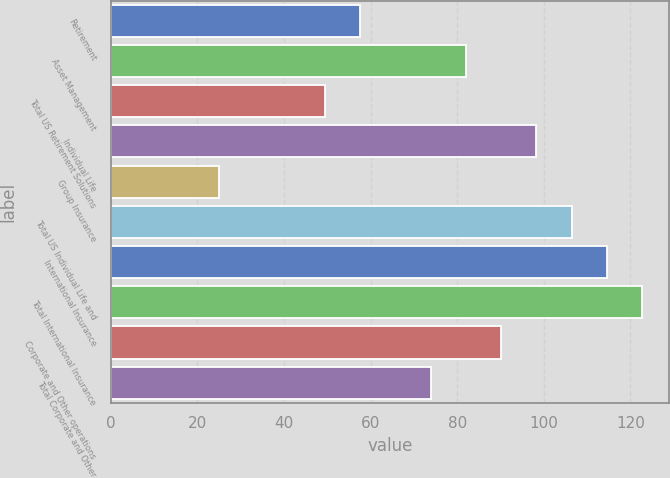Convert chart to OTSL. <chart><loc_0><loc_0><loc_500><loc_500><bar_chart><fcel>Retirement<fcel>Asset Management<fcel>Total US Retirement Solutions<fcel>Individual Life<fcel>Group Insurance<fcel>Total US Individual Life and<fcel>International Insurance<fcel>Total International Insurance<fcel>Corporate and Other operations<fcel>Total Corporate and Other<nl><fcel>57.62<fcel>82.04<fcel>49.48<fcel>98.32<fcel>25.06<fcel>106.46<fcel>114.6<fcel>122.74<fcel>90.18<fcel>73.9<nl></chart> 